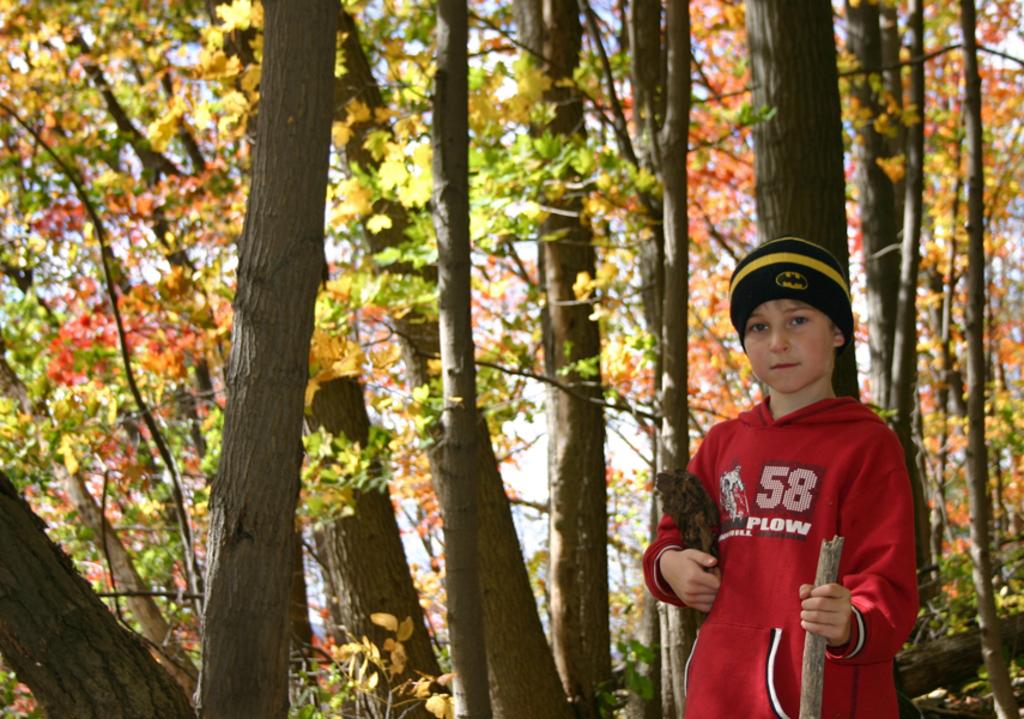What digits are on the hoodie?
Offer a terse response. 58. What word is written under "58"?
Ensure brevity in your answer.  Plow. 